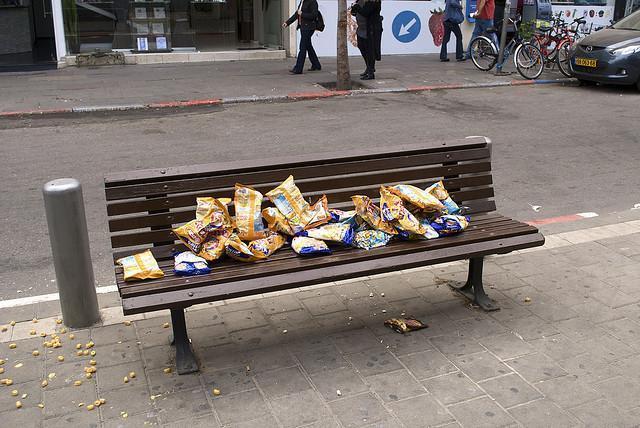How many cars are in the background?
Give a very brief answer. 1. 